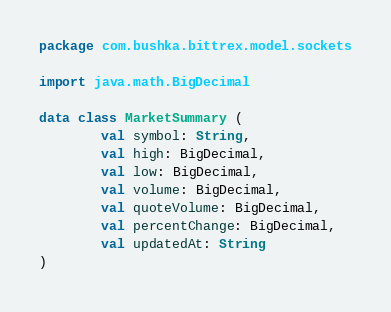Convert code to text. <code><loc_0><loc_0><loc_500><loc_500><_Kotlin_>package com.bushka.bittrex.model.sockets

import java.math.BigDecimal

data class MarketSummary (
        val symbol: String,
        val high: BigDecimal,
        val low: BigDecimal,
        val volume: BigDecimal,
        val quoteVolume: BigDecimal,
        val percentChange: BigDecimal,
        val updatedAt: String
)</code> 